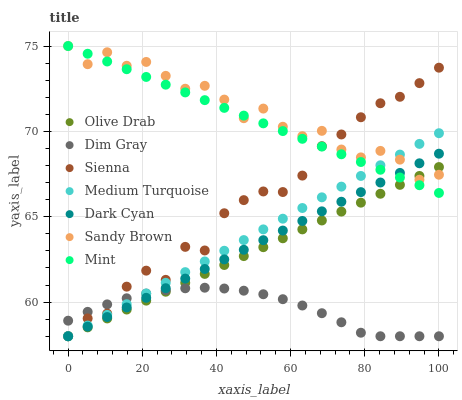Does Dim Gray have the minimum area under the curve?
Answer yes or no. Yes. Does Sandy Brown have the maximum area under the curve?
Answer yes or no. Yes. Does Mint have the minimum area under the curve?
Answer yes or no. No. Does Mint have the maximum area under the curve?
Answer yes or no. No. Is Dark Cyan the smoothest?
Answer yes or no. Yes. Is Sandy Brown the roughest?
Answer yes or no. Yes. Is Mint the smoothest?
Answer yes or no. No. Is Mint the roughest?
Answer yes or no. No. Does Dim Gray have the lowest value?
Answer yes or no. Yes. Does Mint have the lowest value?
Answer yes or no. No. Does Sandy Brown have the highest value?
Answer yes or no. Yes. Does Sienna have the highest value?
Answer yes or no. No. Is Dim Gray less than Sandy Brown?
Answer yes or no. Yes. Is Mint greater than Dim Gray?
Answer yes or no. Yes. Does Sienna intersect Dim Gray?
Answer yes or no. Yes. Is Sienna less than Dim Gray?
Answer yes or no. No. Is Sienna greater than Dim Gray?
Answer yes or no. No. Does Dim Gray intersect Sandy Brown?
Answer yes or no. No. 